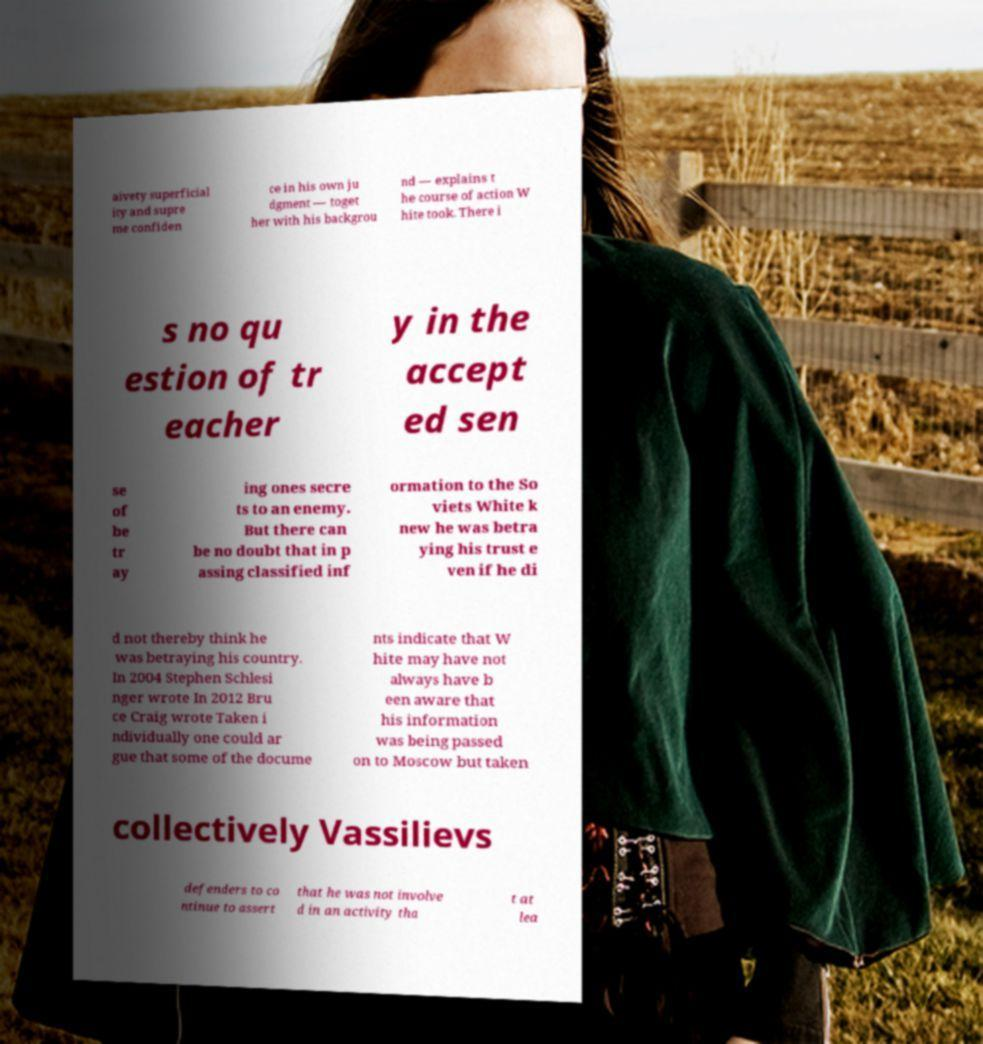What messages or text are displayed in this image? I need them in a readable, typed format. aivety superficial ity and supre me confiden ce in his own ju dgment — toget her with his backgrou nd — explains t he course of action W hite took. There i s no qu estion of tr eacher y in the accept ed sen se of be tr ay ing ones secre ts to an enemy. But there can be no doubt that in p assing classified inf ormation to the So viets White k new he was betra ying his trust e ven if he di d not thereby think he was betraying his country. In 2004 Stephen Schlesi nger wrote In 2012 Bru ce Craig wrote Taken i ndividually one could ar gue that some of the docume nts indicate that W hite may have not always have b een aware that his information was being passed on to Moscow but taken collectively Vassilievs defenders to co ntinue to assert that he was not involve d in an activity tha t at lea 